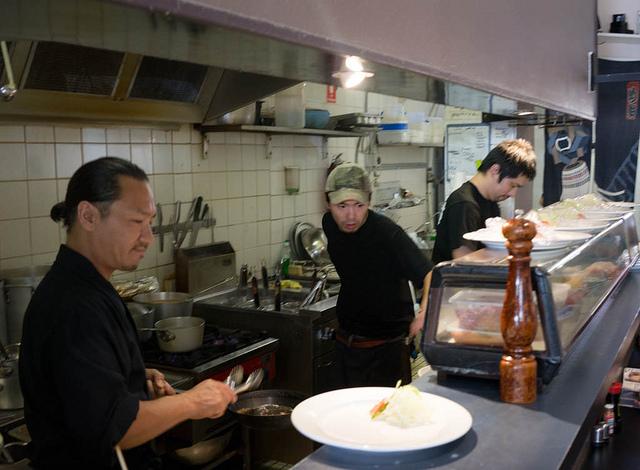How many people are in the kitchen?
Concise answer only. 3. What color is the wall in the kitchen?
Concise answer only. White. What color is the man's hat?
Answer briefly. Green. What is pepper grinder made of?
Keep it brief. Wood. 